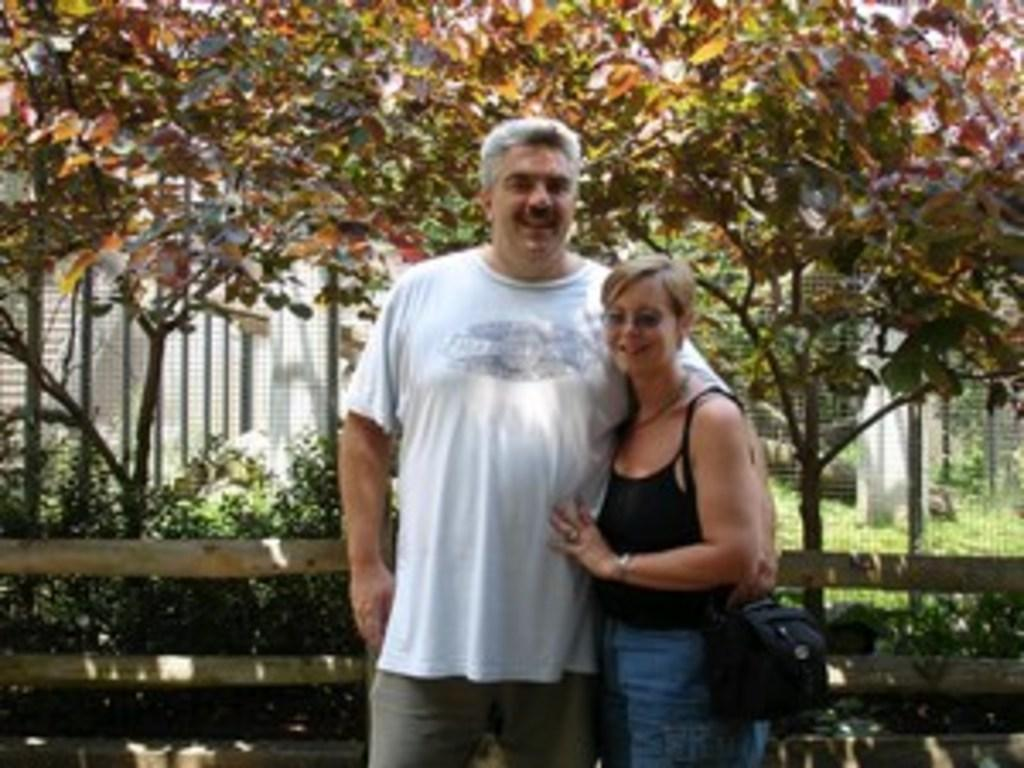Who can be seen in the image? There is a man and a woman in the image. What are the man and woman doing in the image? The man and woman are standing and smiling. What type of barrier can be seen in the image? There is a wooden fence in the image. What type of vegetation is visible in the image? Trees and bushes are present in the image. What is visible in the background of the image? There is a fence in the background of the image. What type of beds can be seen in the image? There are no beds present in the image. What is the man and woman about to start in the image? The image does not depict any action or activity that suggests the man and woman are about to start something. 